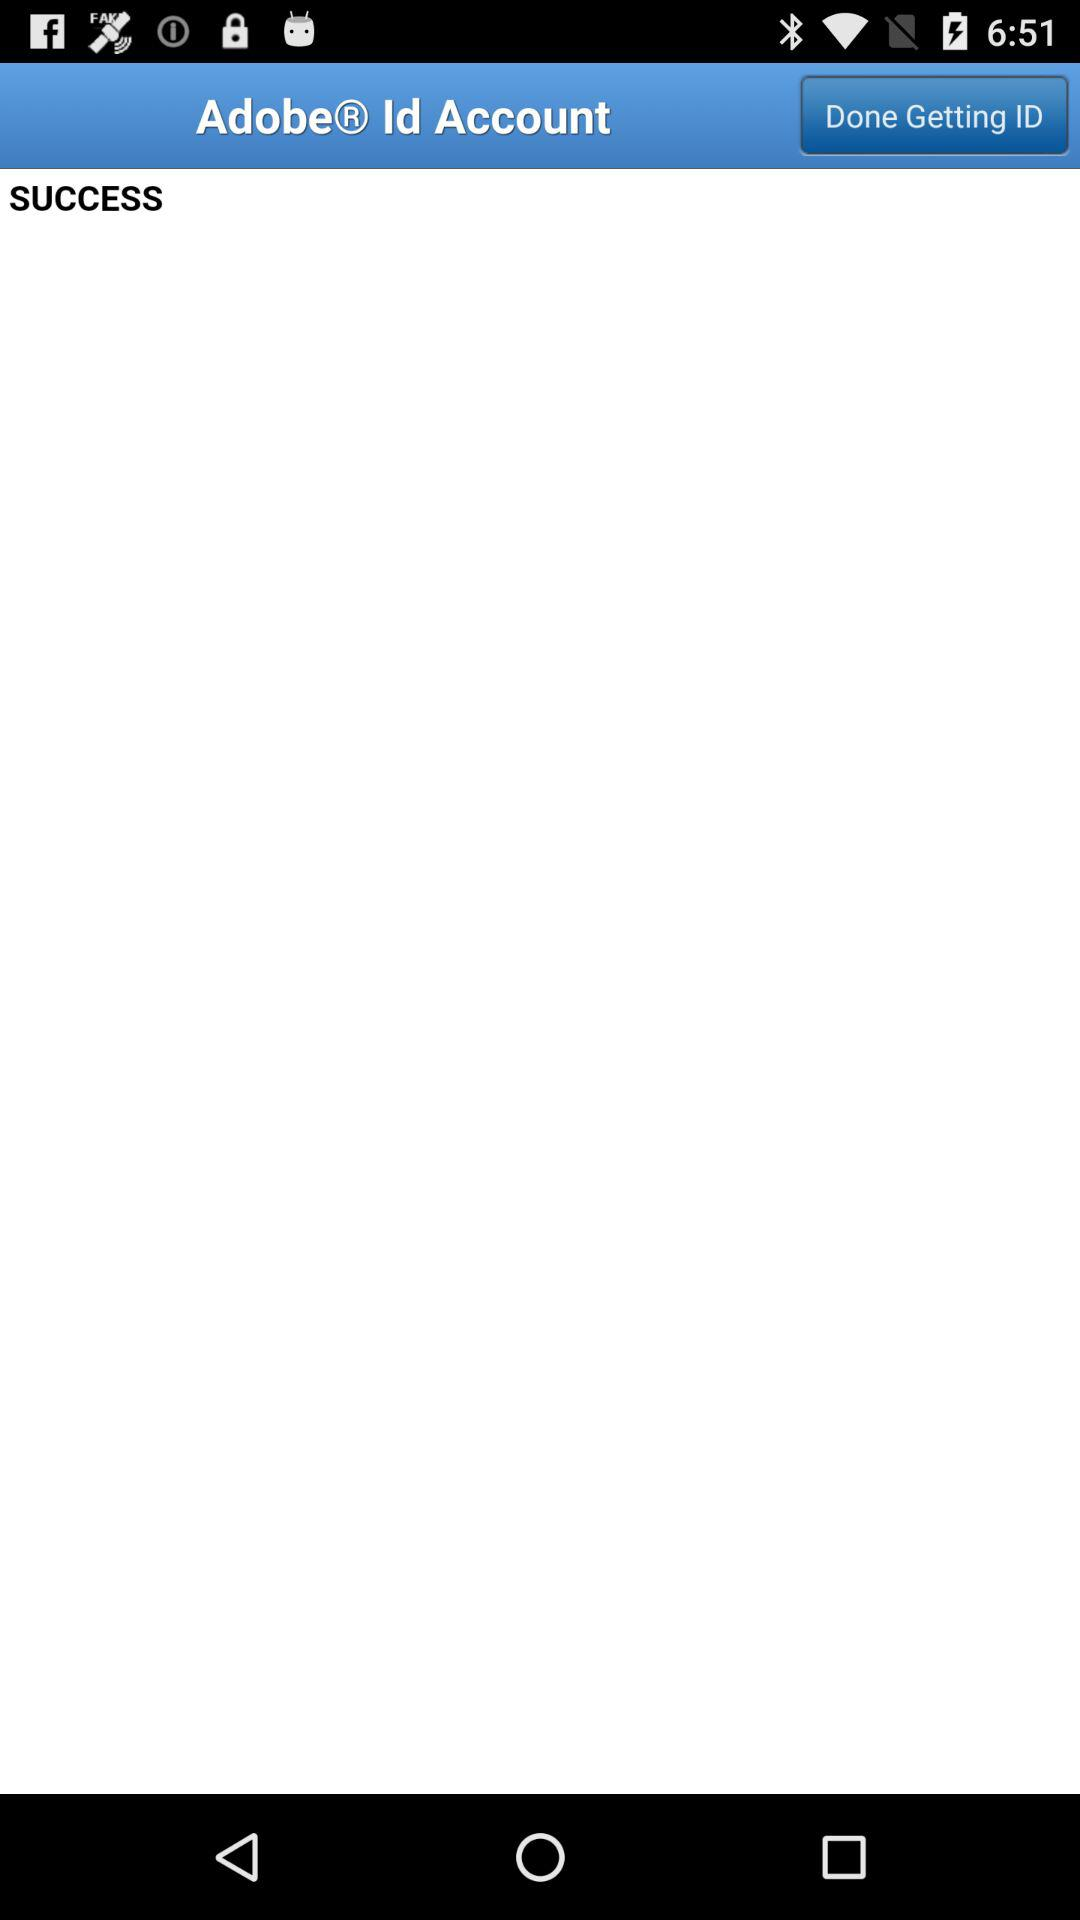What is the app name?
When the provided information is insufficient, respond with <no answer>. <no answer> 